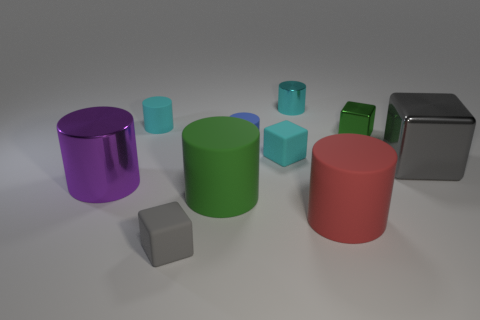Subtract 1 cylinders. How many cylinders are left? 5 Subtract all small blue cylinders. How many cylinders are left? 5 Subtract all blue cylinders. How many cylinders are left? 5 Subtract all green cylinders. Subtract all blue spheres. How many cylinders are left? 5 Subtract all cylinders. How many objects are left? 4 Subtract 1 purple cylinders. How many objects are left? 9 Subtract all cyan things. Subtract all tiny green shiny cubes. How many objects are left? 6 Add 3 tiny rubber blocks. How many tiny rubber blocks are left? 5 Add 6 large metal cylinders. How many large metal cylinders exist? 7 